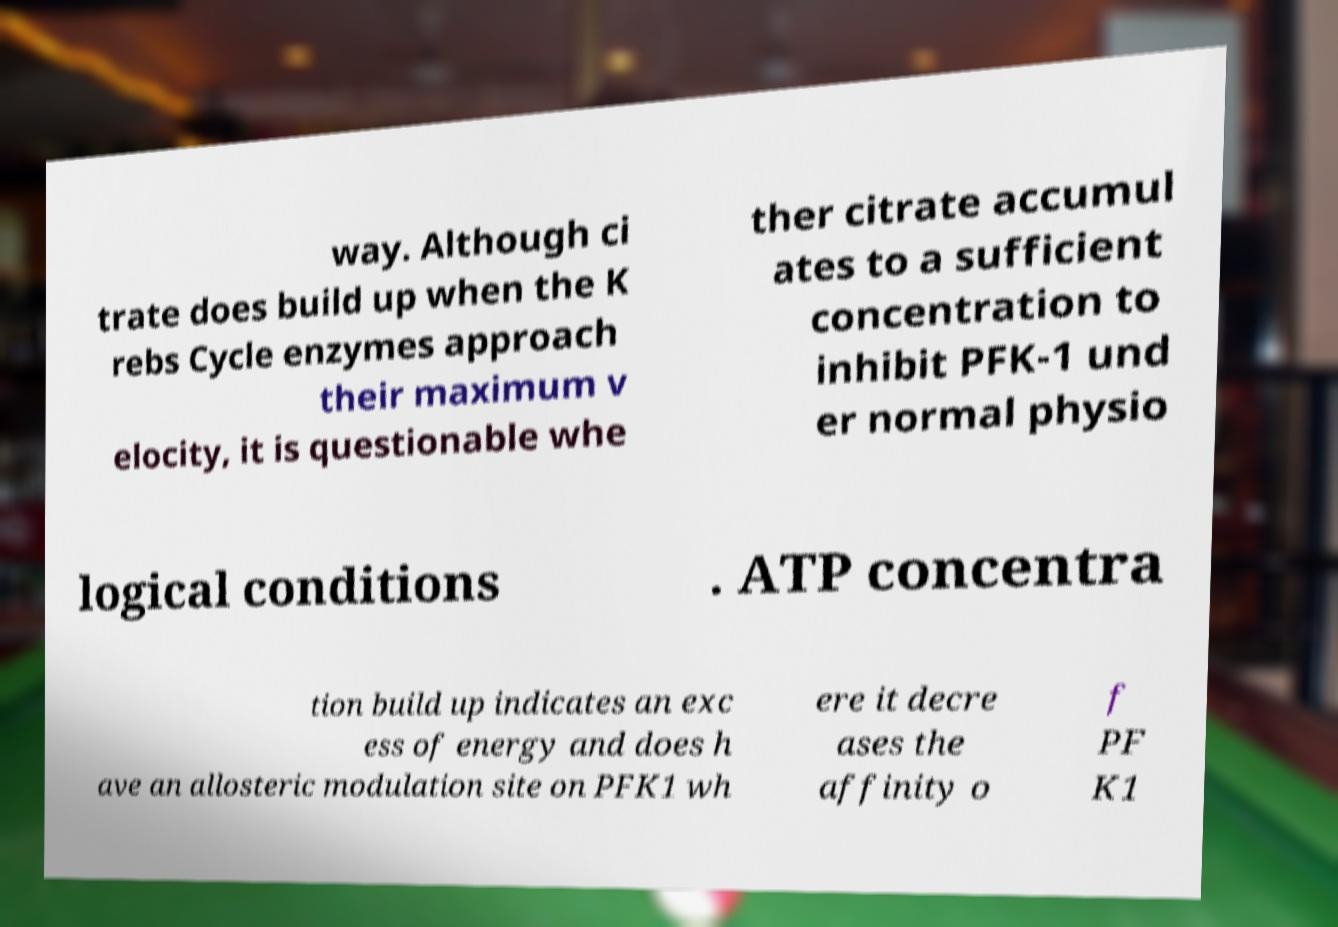Could you assist in decoding the text presented in this image and type it out clearly? way. Although ci trate does build up when the K rebs Cycle enzymes approach their maximum v elocity, it is questionable whe ther citrate accumul ates to a sufficient concentration to inhibit PFK-1 und er normal physio logical conditions . ATP concentra tion build up indicates an exc ess of energy and does h ave an allosteric modulation site on PFK1 wh ere it decre ases the affinity o f PF K1 